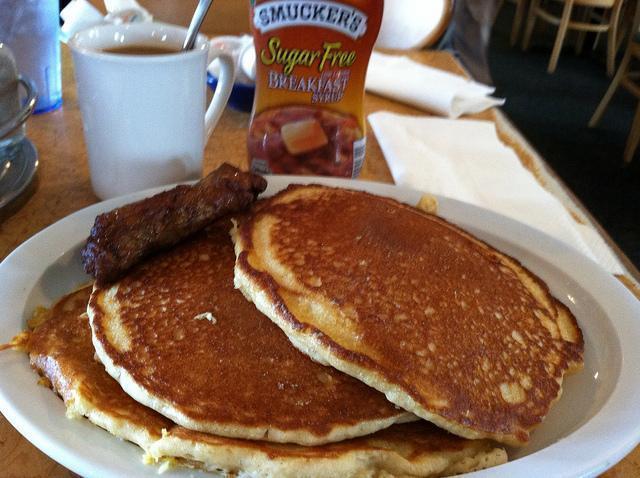What is the Smucker's product replacing?
Select the accurate response from the four choices given to answer the question.
Options: Corn syrup, date syrup, maple syrup, agave nectar. Maple syrup. 